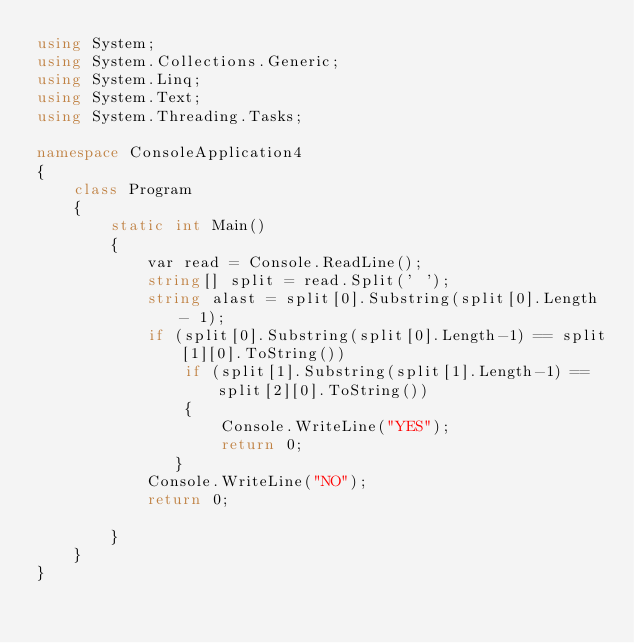<code> <loc_0><loc_0><loc_500><loc_500><_C#_>using System;
using System.Collections.Generic;
using System.Linq;
using System.Text;
using System.Threading.Tasks;

namespace ConsoleApplication4
{
    class Program
    {
        static int Main()
        {
            var read = Console.ReadLine();
            string[] split = read.Split(' ');
            string alast = split[0].Substring(split[0].Length - 1);
            if (split[0].Substring(split[0].Length-1) == split[1][0].ToString())
                if (split[1].Substring(split[1].Length-1) == split[2][0].ToString())
                {
                    Console.WriteLine("YES");
                    return 0;
               }
            Console.WriteLine("NO");
            return 0;

        }
    }
}
</code> 